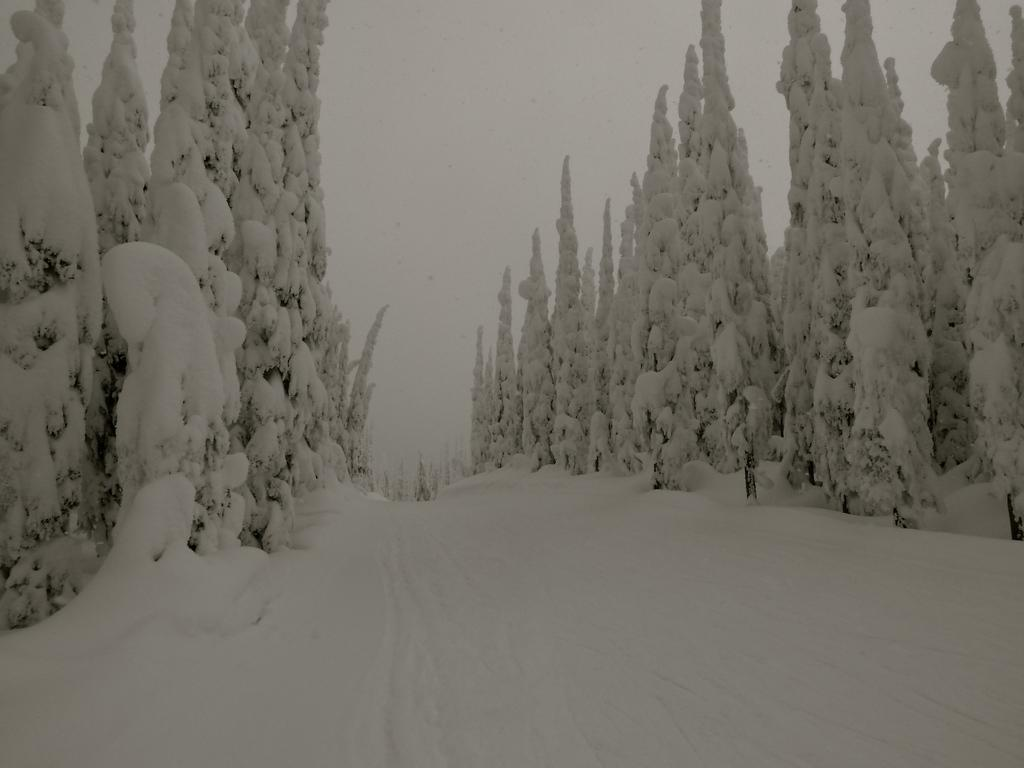What is the primary feature of the landscape in the image? There is snow in the image. What else can be seen in the image besides the snow? There are trees in the image, fully covered with snow. What can be seen in the background of the image? The sky is visible in the background of the image. How many cows are grazing in the snow in the image? There are no cows present in the image; it only features snow-covered trees and the sky. 